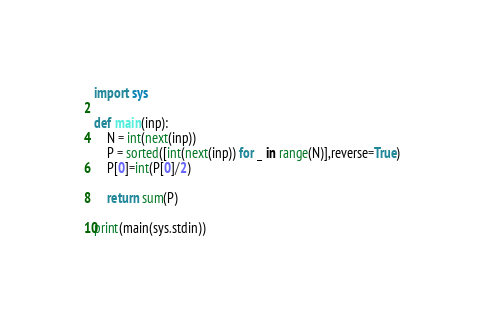Convert code to text. <code><loc_0><loc_0><loc_500><loc_500><_Python_>import sys

def main(inp):
    N = int(next(inp))
    P = sorted([int(next(inp)) for _ in range(N)],reverse=True)
    P[0]=int(P[0]/2)
    
    return sum(P)
  
print(main(sys.stdin))</code> 